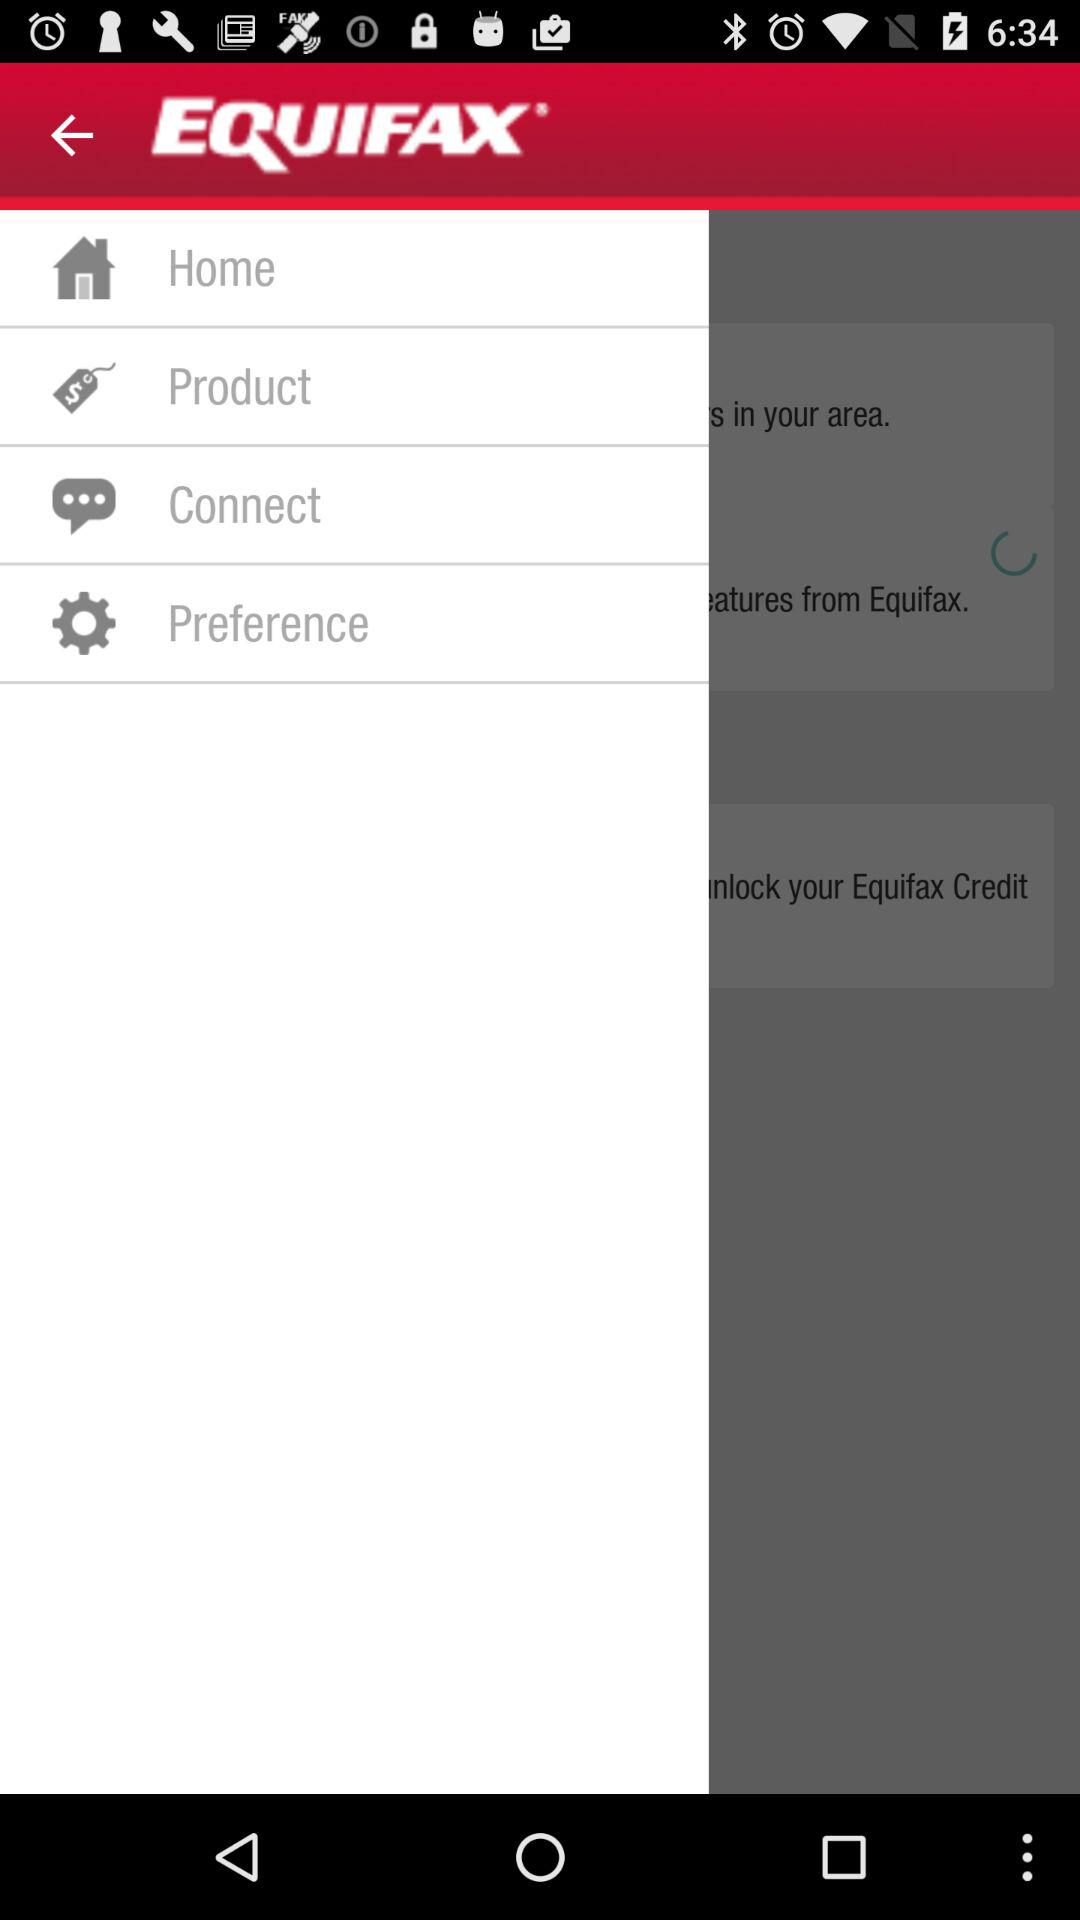What is the application name? The application name is "EQUIFAX". 